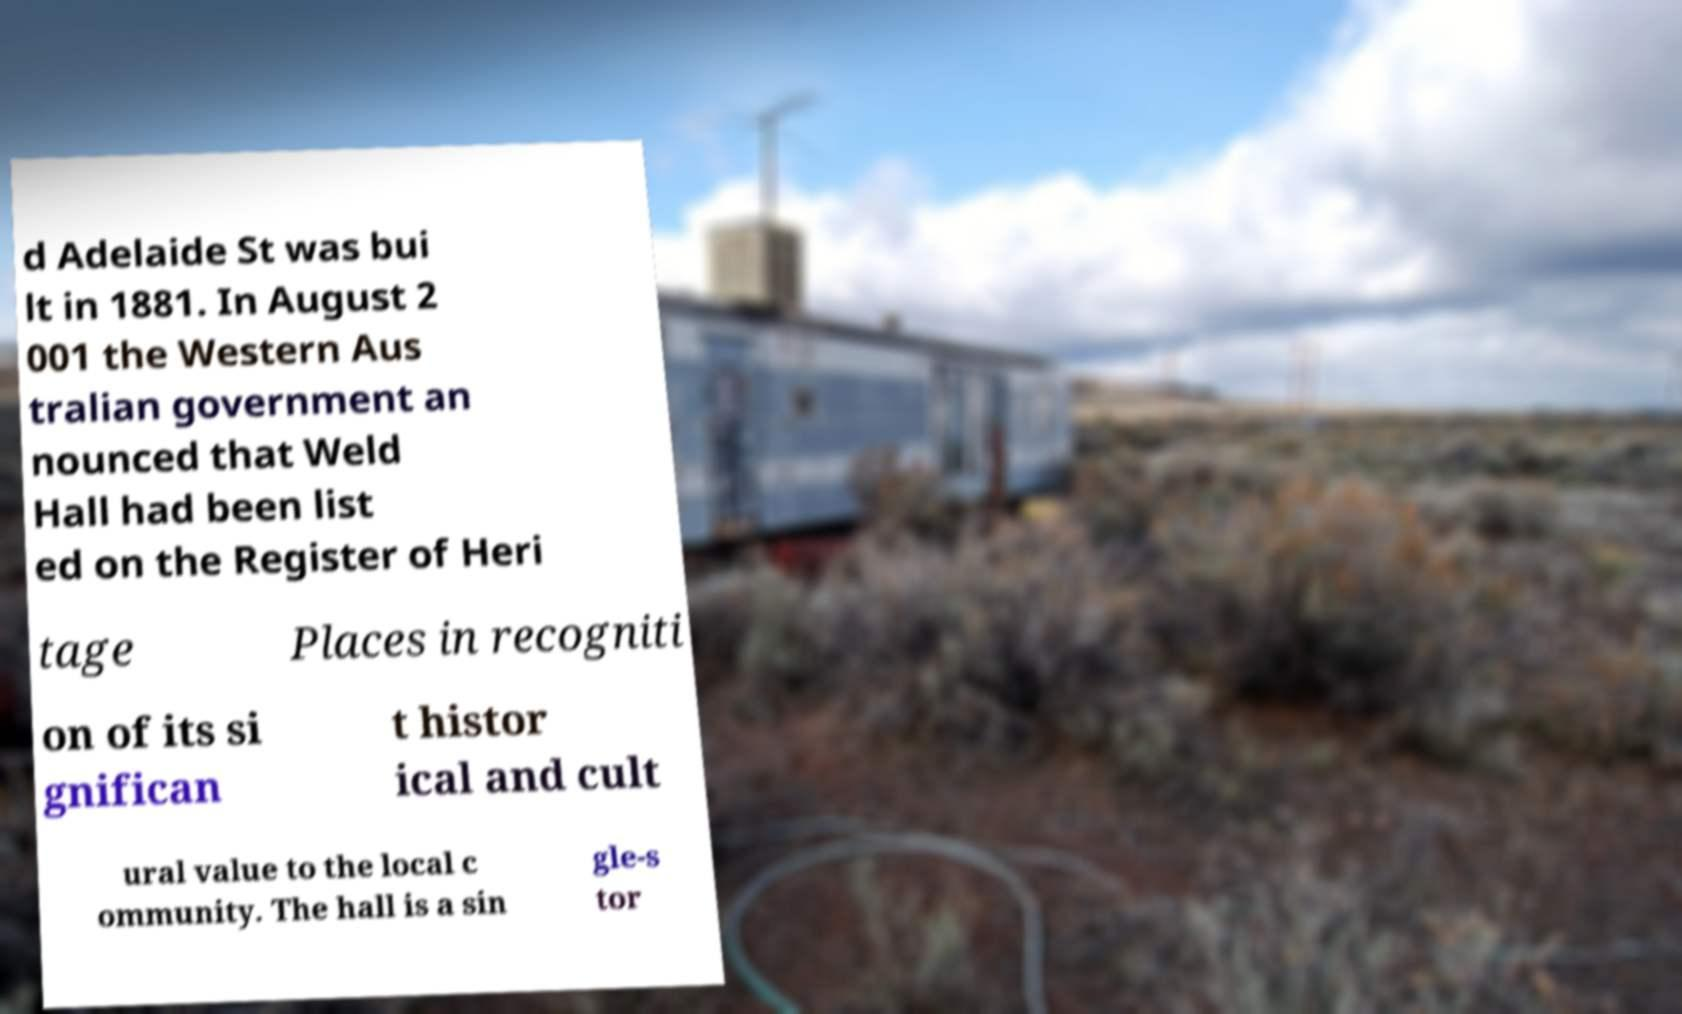Could you assist in decoding the text presented in this image and type it out clearly? d Adelaide St was bui lt in 1881. In August 2 001 the Western Aus tralian government an nounced that Weld Hall had been list ed on the Register of Heri tage Places in recogniti on of its si gnifican t histor ical and cult ural value to the local c ommunity. The hall is a sin gle-s tor 